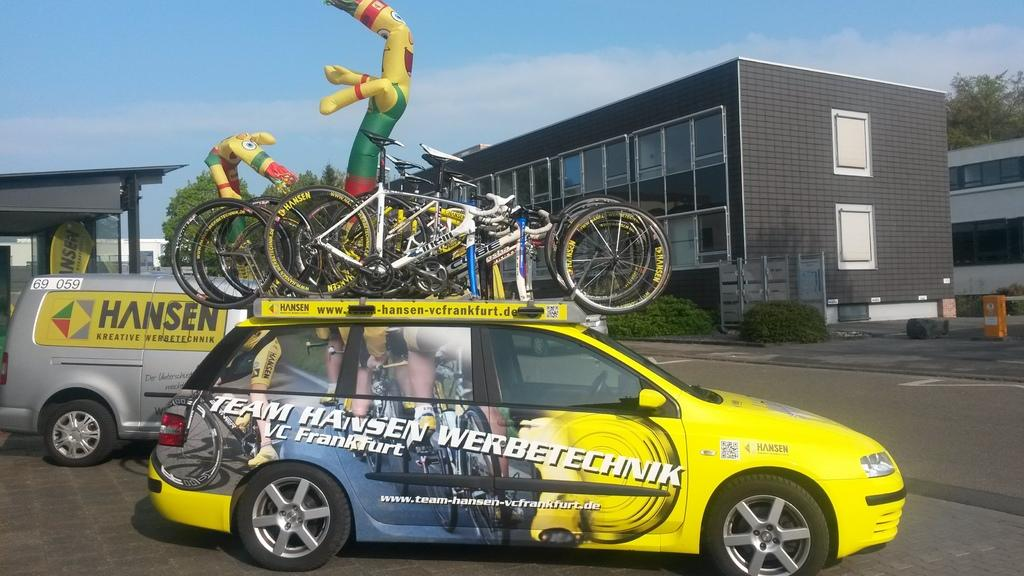<image>
Write a terse but informative summary of the picture. Yellow car which says "Team Hansen" on it. 